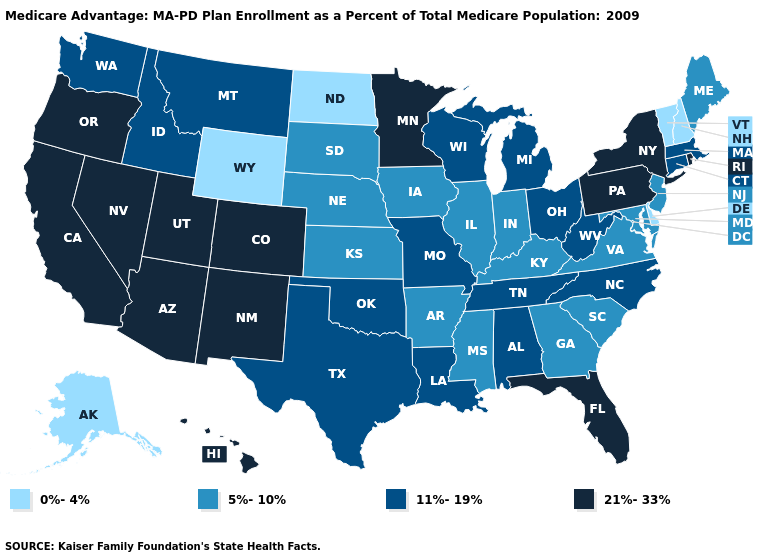Does Alaska have the lowest value in the USA?
Be succinct. Yes. What is the highest value in states that border Oregon?
Short answer required. 21%-33%. Which states have the lowest value in the West?
Give a very brief answer. Alaska, Wyoming. What is the highest value in the USA?
Keep it brief. 21%-33%. What is the value of Georgia?
Give a very brief answer. 5%-10%. What is the highest value in the West ?
Concise answer only. 21%-33%. What is the value of Wisconsin?
Give a very brief answer. 11%-19%. Which states have the lowest value in the USA?
Short answer required. Alaska, Delaware, North Dakota, New Hampshire, Vermont, Wyoming. Does Louisiana have a lower value than Washington?
Answer briefly. No. Name the states that have a value in the range 0%-4%?
Concise answer only. Alaska, Delaware, North Dakota, New Hampshire, Vermont, Wyoming. What is the value of Colorado?
Quick response, please. 21%-33%. What is the value of Alabama?
Give a very brief answer. 11%-19%. What is the lowest value in the South?
Concise answer only. 0%-4%. What is the lowest value in the MidWest?
Concise answer only. 0%-4%. Name the states that have a value in the range 0%-4%?
Give a very brief answer. Alaska, Delaware, North Dakota, New Hampshire, Vermont, Wyoming. 